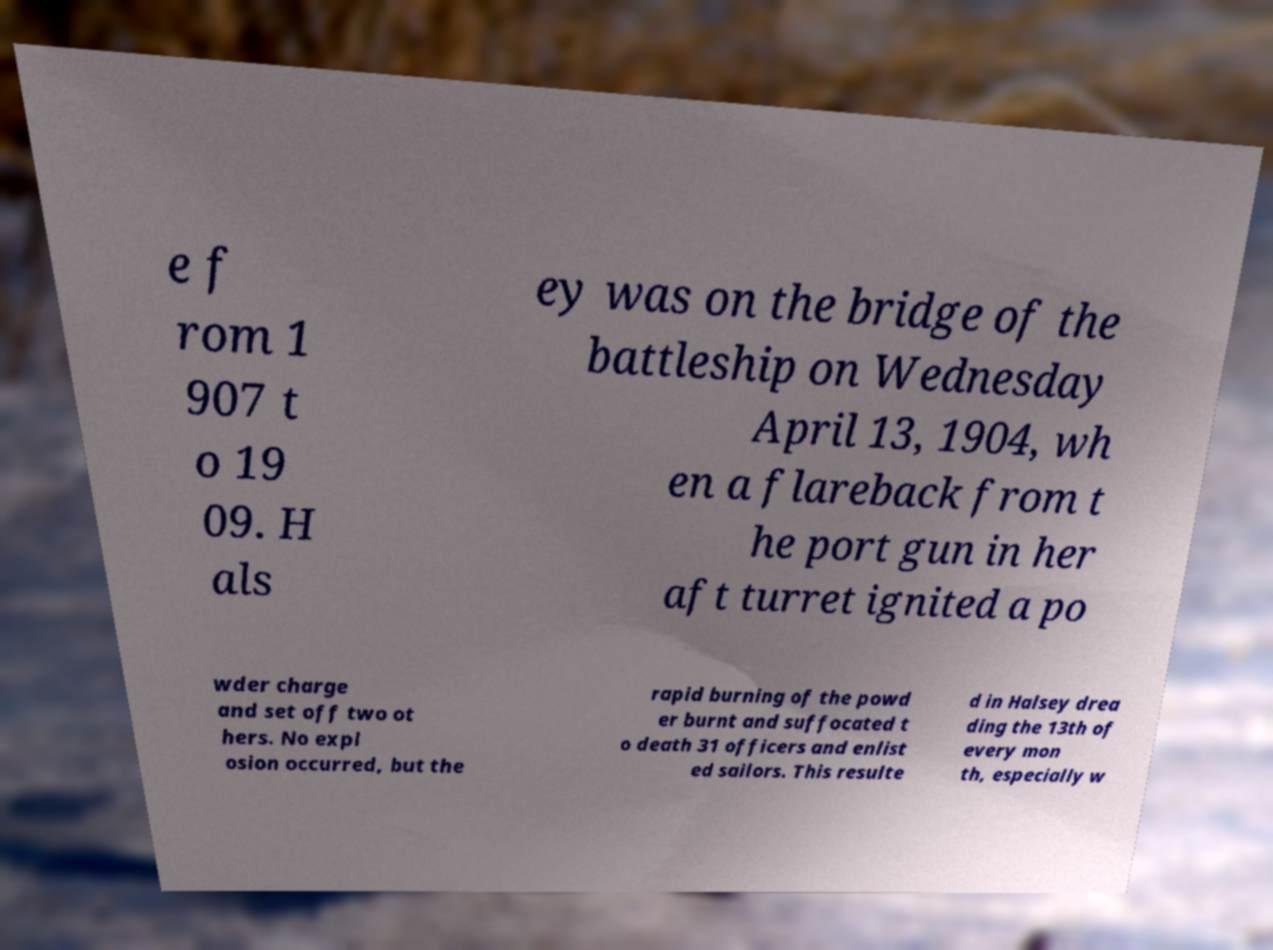Can you accurately transcribe the text from the provided image for me? e f rom 1 907 t o 19 09. H als ey was on the bridge of the battleship on Wednesday April 13, 1904, wh en a flareback from t he port gun in her aft turret ignited a po wder charge and set off two ot hers. No expl osion occurred, but the rapid burning of the powd er burnt and suffocated t o death 31 officers and enlist ed sailors. This resulte d in Halsey drea ding the 13th of every mon th, especially w 